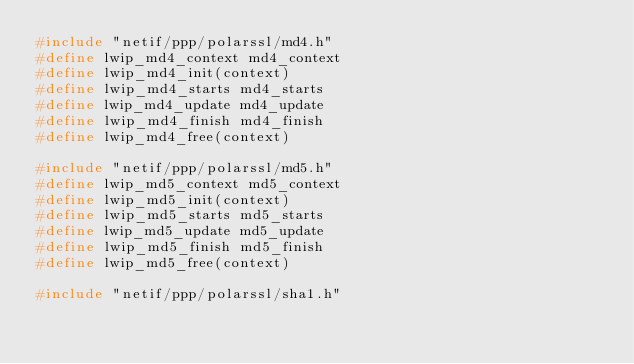<code> <loc_0><loc_0><loc_500><loc_500><_C_>#include "netif/ppp/polarssl/md4.h"
#define lwip_md4_context md4_context
#define lwip_md4_init(context)
#define lwip_md4_starts md4_starts
#define lwip_md4_update md4_update
#define lwip_md4_finish md4_finish
#define lwip_md4_free(context)

#include "netif/ppp/polarssl/md5.h"
#define lwip_md5_context md5_context
#define lwip_md5_init(context)
#define lwip_md5_starts md5_starts
#define lwip_md5_update md5_update
#define lwip_md5_finish md5_finish
#define lwip_md5_free(context)

#include "netif/ppp/polarssl/sha1.h"</code> 